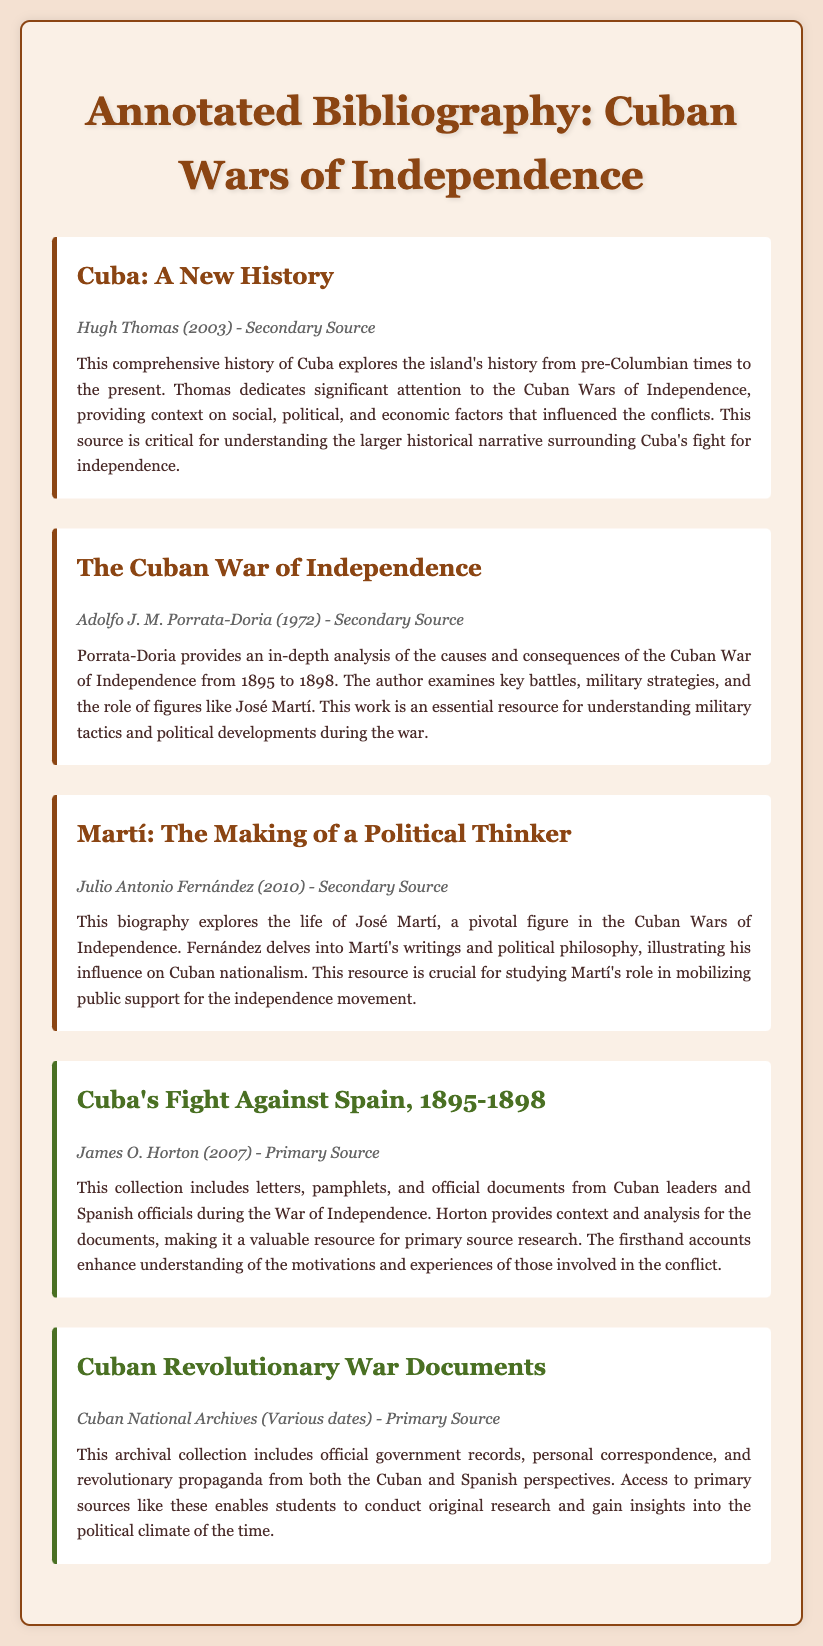What is the title of the secondary source by Hugh Thomas? The document lists "Cuba: A New History" as the title of the secondary source by Hugh Thomas.
Answer: Cuba: A New History Who is the author of the primary source "Cuba's Fight Against Spain, 1895-1898"? The author of the primary source is James O. Horton, as stated in the document.
Answer: James O. Horton What year was "The Cuban War of Independence" published? The document provides the publication year of "The Cuban War of Independence" as 1972.
Answer: 1972 Which figure is highlighted in the biography "Martí: The Making of a Political Thinker"? The biography focuses on José Martí, as mentioned in the annotation.
Answer: José Martí What type of source is "Cuban Revolutionary War Documents"? According to the document, "Cuban Revolutionary War Documents" is classified as a primary source.
Answer: Primary Source What is a significant focus of Hugh Thomas's book? The book "Cuba: A New History" dedicates significant attention to the Cuban Wars of Independence.
Answer: Cuban Wars of Independence Why is "Cuba's Fight Against Spain, 1895-1898" considered valuable? The collection includes letters, pamphlets, and official documents from the War of Independence, providing firsthand accounts that enhance understanding.
Answer: Firsthand accounts Who are the perspectives included in the "Cuban Revolutionary War Documents"? The archival collection presents documents from both the Cuban and Spanish perspectives.
Answer: Cuban and Spanish perspectives What is the general topic of the document? The document serves as an annotated bibliography on primary and secondary sources regarding the Cuban Wars of Independence.
Answer: Annotated bibliography 